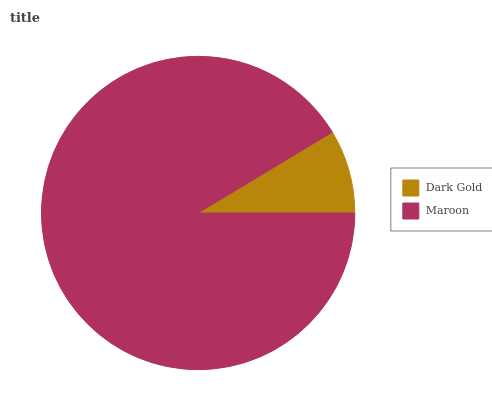Is Dark Gold the minimum?
Answer yes or no. Yes. Is Maroon the maximum?
Answer yes or no. Yes. Is Maroon the minimum?
Answer yes or no. No. Is Maroon greater than Dark Gold?
Answer yes or no. Yes. Is Dark Gold less than Maroon?
Answer yes or no. Yes. Is Dark Gold greater than Maroon?
Answer yes or no. No. Is Maroon less than Dark Gold?
Answer yes or no. No. Is Maroon the high median?
Answer yes or no. Yes. Is Dark Gold the low median?
Answer yes or no. Yes. Is Dark Gold the high median?
Answer yes or no. No. Is Maroon the low median?
Answer yes or no. No. 